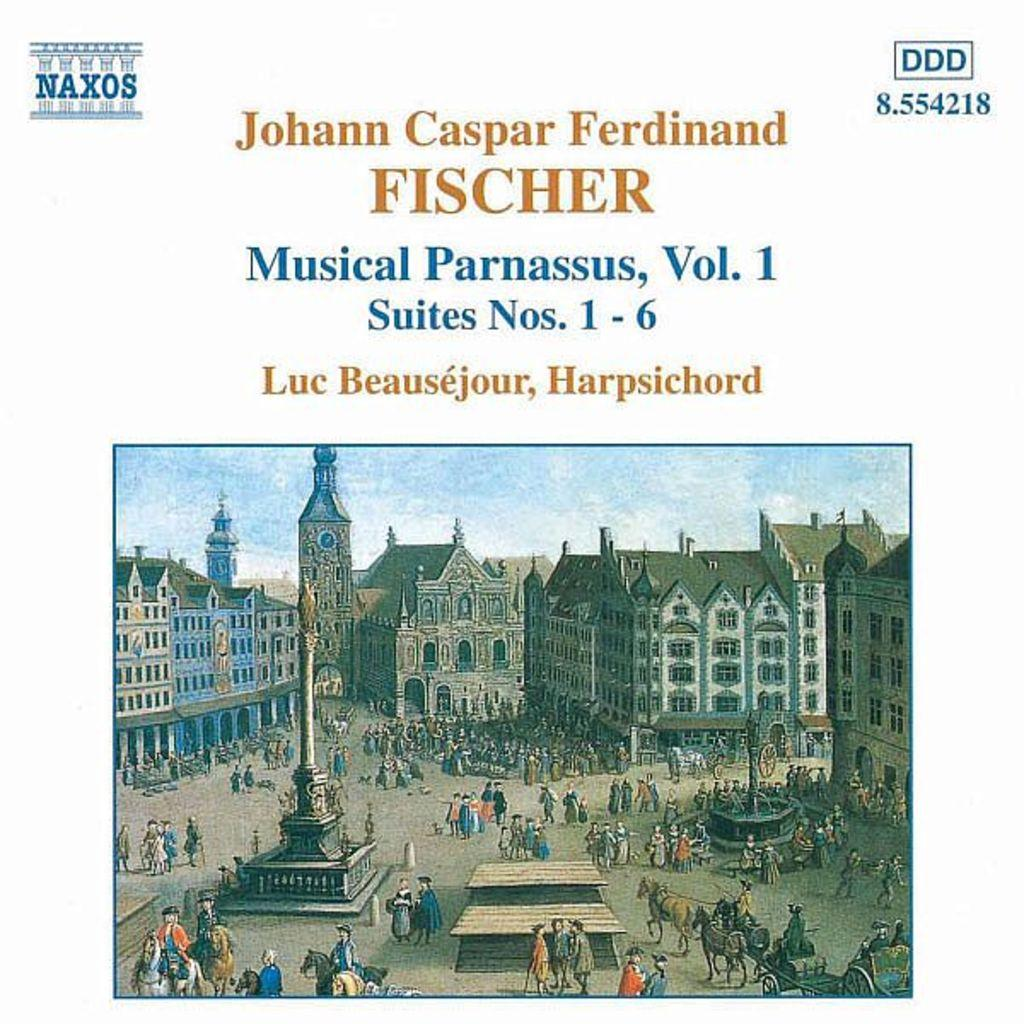Who is present in the image? There are people in the image. What are the people doing with the horses? The people are with horses in the image. What structures can be seen in the background? There are buildings in the image. What type of reward is being given to the tree in the image? There is no tree present in the image, and therefore no reward can be given to it. 